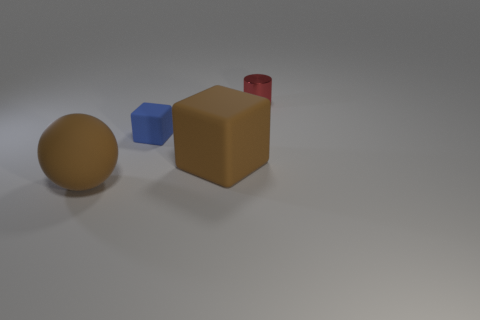What color is the tiny thing left of the tiny red cylinder?
Make the answer very short. Blue. Are there more matte things that are in front of the small block than small metal cylinders?
Provide a succinct answer. Yes. What number of other things are the same size as the brown ball?
Ensure brevity in your answer.  1. What number of red shiny cylinders are to the right of the tiny red cylinder?
Offer a very short reply. 0. Are there the same number of large balls that are right of the sphere and tiny blue blocks right of the large brown matte cube?
Offer a very short reply. Yes. There is another object that is the same shape as the tiny rubber thing; what size is it?
Give a very brief answer. Large. What shape is the brown matte thing that is behind the large matte sphere?
Your answer should be very brief. Cube. Is the large brown object that is on the left side of the tiny rubber thing made of the same material as the object behind the small blue rubber object?
Offer a very short reply. No. There is a shiny thing; what shape is it?
Keep it short and to the point. Cylinder. Are there an equal number of big brown spheres behind the small metallic object and big gray objects?
Your answer should be compact. Yes. 